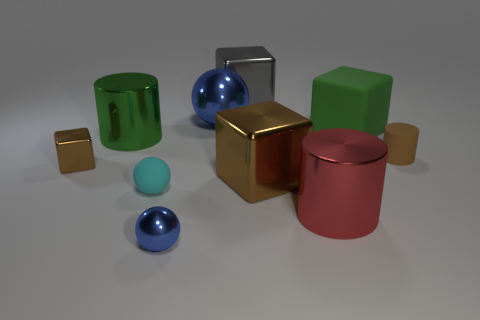Subtract all gray blocks. How many blocks are left? 3 Subtract all big gray shiny cubes. How many cubes are left? 3 Subtract 0 red spheres. How many objects are left? 10 Subtract all cylinders. How many objects are left? 7 Subtract 2 spheres. How many spheres are left? 1 Subtract all purple cylinders. Subtract all brown balls. How many cylinders are left? 3 Subtract all brown spheres. How many green blocks are left? 1 Subtract all large brown metallic blocks. Subtract all large blue metallic things. How many objects are left? 8 Add 4 tiny metal balls. How many tiny metal balls are left? 5 Add 4 cylinders. How many cylinders exist? 7 